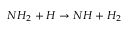Convert formula to latex. <formula><loc_0><loc_0><loc_500><loc_500>N H _ { 2 } + H \rightarrow N H + H _ { 2 }</formula> 